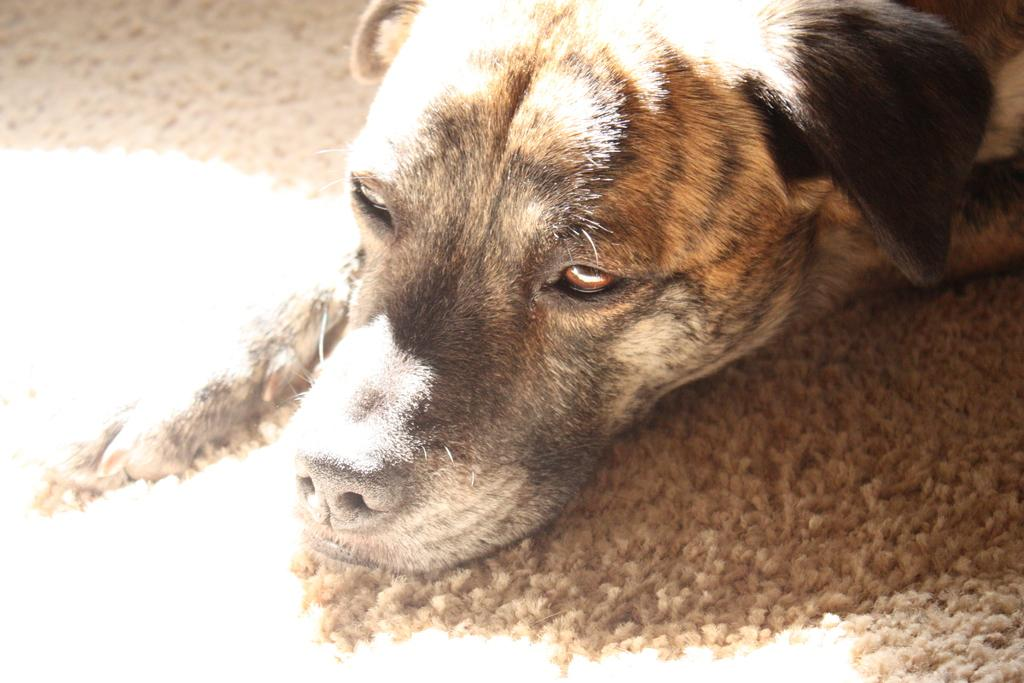What animal can be seen in the picture? There is a dog in the picture. What part of the dog is visible? The dog's head portion is visible. What is the dog's position in the picture? The dog is laying on the ground. What is the lighting condition in the picture? There is bright sunlight falling on the dog's surface. What type of button is the governor wearing in the image? There is no governor or button present in the image; it features a dog laying on the ground. What kind of crack is visible on the dog's surface? There is no crack visible on the dog's surface in the image. 